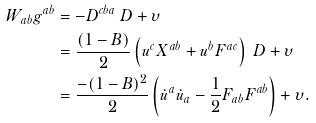<formula> <loc_0><loc_0><loc_500><loc_500>W _ { a b } g ^ { a b } & = - D ^ { c b a } \ D + \upsilon \\ & = \frac { ( 1 - B ) } { 2 } \left ( u ^ { c } X ^ { a b } + u ^ { b } F ^ { a c } \right ) \ D + \upsilon \\ & = \frac { - ( 1 - B ) ^ { 2 } } { 2 } \left ( \dot { u } ^ { a } \dot { u } _ { a } - \frac { 1 } { 2 } F _ { a b } F ^ { a b } \right ) + \upsilon .</formula> 